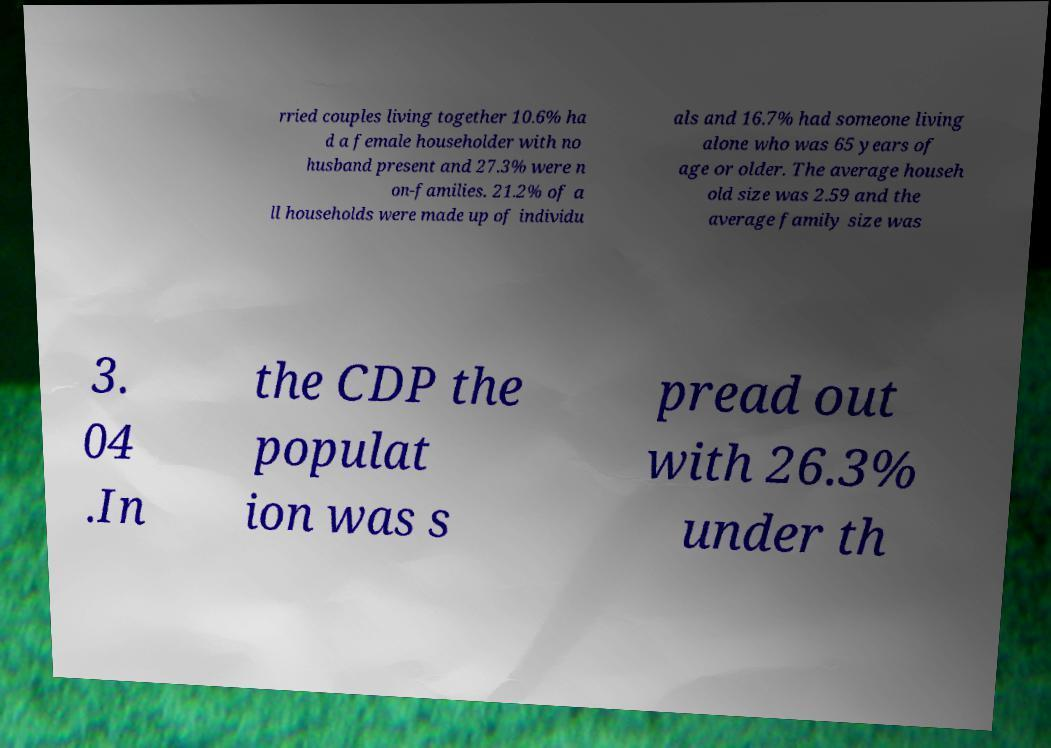For documentation purposes, I need the text within this image transcribed. Could you provide that? rried couples living together 10.6% ha d a female householder with no husband present and 27.3% were n on-families. 21.2% of a ll households were made up of individu als and 16.7% had someone living alone who was 65 years of age or older. The average househ old size was 2.59 and the average family size was 3. 04 .In the CDP the populat ion was s pread out with 26.3% under th 